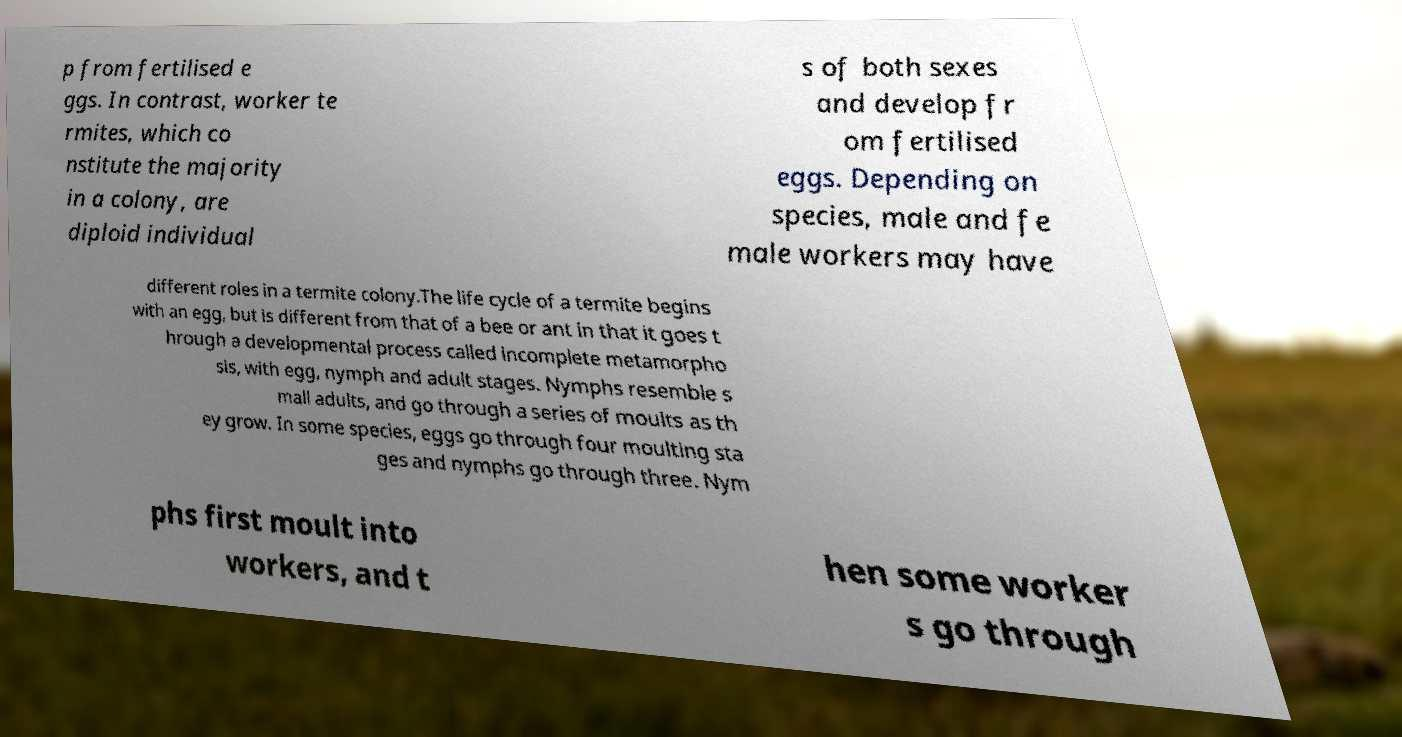Please identify and transcribe the text found in this image. p from fertilised e ggs. In contrast, worker te rmites, which co nstitute the majority in a colony, are diploid individual s of both sexes and develop fr om fertilised eggs. Depending on species, male and fe male workers may have different roles in a termite colony.The life cycle of a termite begins with an egg, but is different from that of a bee or ant in that it goes t hrough a developmental process called incomplete metamorpho sis, with egg, nymph and adult stages. Nymphs resemble s mall adults, and go through a series of moults as th ey grow. In some species, eggs go through four moulting sta ges and nymphs go through three. Nym phs first moult into workers, and t hen some worker s go through 